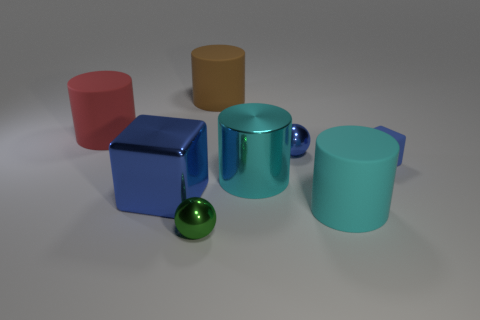Subtract 1 cylinders. How many cylinders are left? 3 Add 1 green shiny spheres. How many objects exist? 9 Subtract all blocks. How many objects are left? 6 Subtract all tiny blue rubber cubes. Subtract all large shiny cubes. How many objects are left? 6 Add 3 tiny blocks. How many tiny blocks are left? 4 Add 4 blue rubber objects. How many blue rubber objects exist? 5 Subtract 1 brown cylinders. How many objects are left? 7 